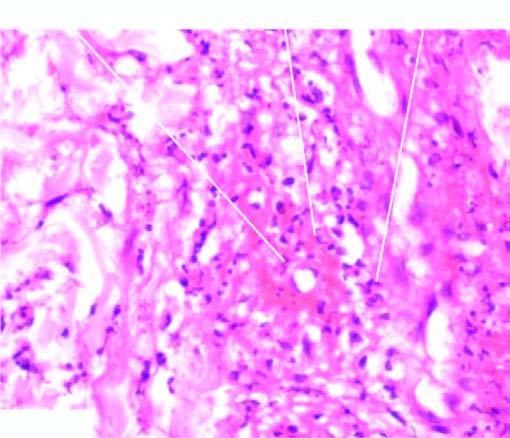what does the vesselwall show?
Answer the question using a single word or phrase. Brightly pink amorphous material and nuclear fragments ofnecrosed neutrophils 